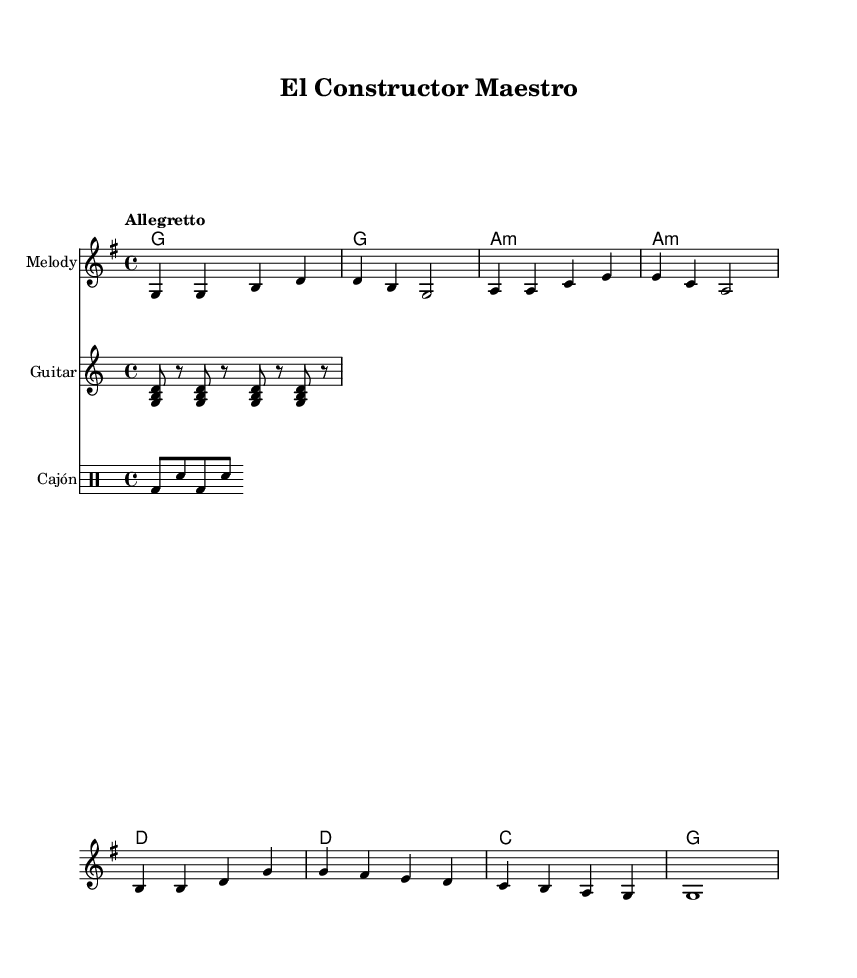What is the key signature of this music? The key signature is G major, which has one sharp (F#). This can be identified by checking the key signature at the beginning of the music sheet, which indicates it is in G major.
Answer: G major What is the time signature of this piece? The time signature is 4/4, indicated at the beginning of the sheet music. This means there are four beats in each measure and a quarter note gets one beat.
Answer: 4/4 What is the tempo marking for the piece? The tempo marking is "Allegretto," which is a moderate tempo typically faster than "Andante" but slower than "Allegro." This is written above the staff where the tempo is indicated.
Answer: Allegretto How many measures are present in the melody section? There are eight measures in the melody section as indicated by the grouping of notes and rests in the melody line. Counting the bars in the melody provides this total.
Answer: Eight What type of instrumentation is used in this sheet music? The instrumentation includes a melody staff, a guitar staff, and a cajón drum staff. This can be identified by the different labeled staves in the score.
Answer: Melody, Guitar, Cajón What is the lyrical theme of the song? The lyrical theme revolves around construction and craftsmanship, with phrases that highlight passion and precision in building, as seen in the provided lyrics.
Answer: Construction and craftsmanship What is the harmonic progression in the piece? The harmonic progression in the piece follows a sequence of G, A minor, D, and C chords. This is deduced from the ChordNames section where the harmonies are explicitly notated.
Answer: G, A minor, D, C 